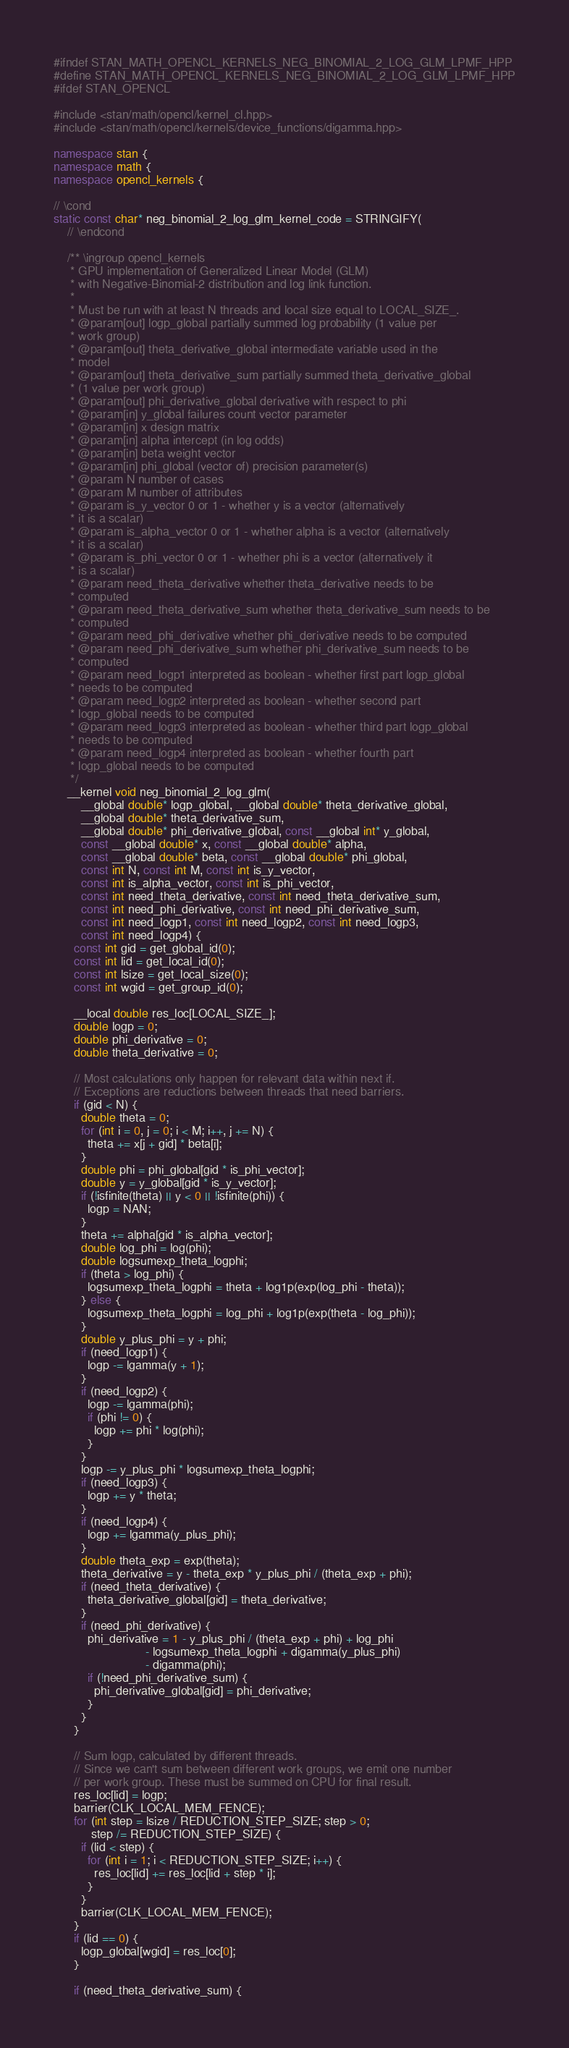Convert code to text. <code><loc_0><loc_0><loc_500><loc_500><_C++_>#ifndef STAN_MATH_OPENCL_KERNELS_NEG_BINOMIAL_2_LOG_GLM_LPMF_HPP
#define STAN_MATH_OPENCL_KERNELS_NEG_BINOMIAL_2_LOG_GLM_LPMF_HPP
#ifdef STAN_OPENCL

#include <stan/math/opencl/kernel_cl.hpp>
#include <stan/math/opencl/kernels/device_functions/digamma.hpp>

namespace stan {
namespace math {
namespace opencl_kernels {

// \cond
static const char* neg_binomial_2_log_glm_kernel_code = STRINGIFY(
    // \endcond

    /** \ingroup opencl_kernels
     * GPU implementation of Generalized Linear Model (GLM)
     * with Negative-Binomial-2 distribution and log link function.
     *
     * Must be run with at least N threads and local size equal to LOCAL_SIZE_.
     * @param[out] logp_global partially summed log probability (1 value per
     * work group)
     * @param[out] theta_derivative_global intermediate variable used in the
     * model
     * @param[out] theta_derivative_sum partially summed theta_derivative_global
     * (1 value per work group)
     * @param[out] phi_derivative_global derivative with respect to phi
     * @param[in] y_global failures count vector parameter
     * @param[in] x design matrix
     * @param[in] alpha intercept (in log odds)
     * @param[in] beta weight vector
     * @param[in] phi_global (vector of) precision parameter(s)
     * @param N number of cases
     * @param M number of attributes
     * @param is_y_vector 0 or 1 - whether y is a vector (alternatively
     * it is a scalar)
     * @param is_alpha_vector 0 or 1 - whether alpha is a vector (alternatively
     * it is a scalar)
     * @param is_phi_vector 0 or 1 - whether phi is a vector (alternatively it
     * is a scalar)
     * @param need_theta_derivative whether theta_derivative needs to be
     * computed
     * @param need_theta_derivative_sum whether theta_derivative_sum needs to be
     * computed
     * @param need_phi_derivative whether phi_derivative needs to be computed
     * @param need_phi_derivative_sum whether phi_derivative_sum needs to be
     * computed
     * @param need_logp1 interpreted as boolean - whether first part logp_global
     * needs to be computed
     * @param need_logp2 interpreted as boolean - whether second part
     * logp_global needs to be computed
     * @param need_logp3 interpreted as boolean - whether third part logp_global
     * needs to be computed
     * @param need_logp4 interpreted as boolean - whether fourth part
     * logp_global needs to be computed
     */
    __kernel void neg_binomial_2_log_glm(
        __global double* logp_global, __global double* theta_derivative_global,
        __global double* theta_derivative_sum,
        __global double* phi_derivative_global, const __global int* y_global,
        const __global double* x, const __global double* alpha,
        const __global double* beta, const __global double* phi_global,
        const int N, const int M, const int is_y_vector,
        const int is_alpha_vector, const int is_phi_vector,
        const int need_theta_derivative, const int need_theta_derivative_sum,
        const int need_phi_derivative, const int need_phi_derivative_sum,
        const int need_logp1, const int need_logp2, const int need_logp3,
        const int need_logp4) {
      const int gid = get_global_id(0);
      const int lid = get_local_id(0);
      const int lsize = get_local_size(0);
      const int wgid = get_group_id(0);

      __local double res_loc[LOCAL_SIZE_];
      double logp = 0;
      double phi_derivative = 0;
      double theta_derivative = 0;

      // Most calculations only happen for relevant data within next if.
      // Exceptions are reductions between threads that need barriers.
      if (gid < N) {
        double theta = 0;
        for (int i = 0, j = 0; i < M; i++, j += N) {
          theta += x[j + gid] * beta[i];
        }
        double phi = phi_global[gid * is_phi_vector];
        double y = y_global[gid * is_y_vector];
        if (!isfinite(theta) || y < 0 || !isfinite(phi)) {
          logp = NAN;
        }
        theta += alpha[gid * is_alpha_vector];
        double log_phi = log(phi);
        double logsumexp_theta_logphi;
        if (theta > log_phi) {
          logsumexp_theta_logphi = theta + log1p(exp(log_phi - theta));
        } else {
          logsumexp_theta_logphi = log_phi + log1p(exp(theta - log_phi));
        }
        double y_plus_phi = y + phi;
        if (need_logp1) {
          logp -= lgamma(y + 1);
        }
        if (need_logp2) {
          logp -= lgamma(phi);
          if (phi != 0) {
            logp += phi * log(phi);
          }
        }
        logp -= y_plus_phi * logsumexp_theta_logphi;
        if (need_logp3) {
          logp += y * theta;
        }
        if (need_logp4) {
          logp += lgamma(y_plus_phi);
        }
        double theta_exp = exp(theta);
        theta_derivative = y - theta_exp * y_plus_phi / (theta_exp + phi);
        if (need_theta_derivative) {
          theta_derivative_global[gid] = theta_derivative;
        }
        if (need_phi_derivative) {
          phi_derivative = 1 - y_plus_phi / (theta_exp + phi) + log_phi
                           - logsumexp_theta_logphi + digamma(y_plus_phi)
                           - digamma(phi);
          if (!need_phi_derivative_sum) {
            phi_derivative_global[gid] = phi_derivative;
          }
        }
      }

      // Sum logp, calculated by different threads.
      // Since we can't sum between different work groups, we emit one number
      // per work group. These must be summed on CPU for final result.
      res_loc[lid] = logp;
      barrier(CLK_LOCAL_MEM_FENCE);
      for (int step = lsize / REDUCTION_STEP_SIZE; step > 0;
           step /= REDUCTION_STEP_SIZE) {
        if (lid < step) {
          for (int i = 1; i < REDUCTION_STEP_SIZE; i++) {
            res_loc[lid] += res_loc[lid + step * i];
          }
        }
        barrier(CLK_LOCAL_MEM_FENCE);
      }
      if (lid == 0) {
        logp_global[wgid] = res_loc[0];
      }

      if (need_theta_derivative_sum) {</code> 